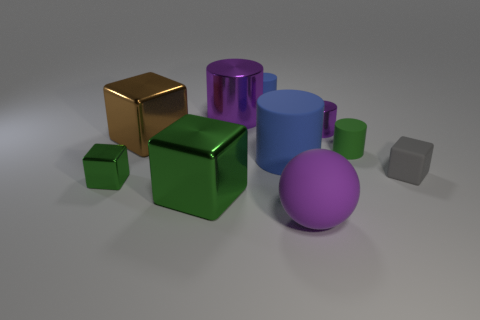The small metallic object that is the same color as the big matte sphere is what shape?
Offer a terse response. Cylinder. Is there anything else of the same color as the small matte cube?
Offer a very short reply. No. Do the green cylinder and the rubber cube have the same size?
Provide a succinct answer. Yes. How many things are either tiny green objects on the right side of the large shiny cylinder or green objects that are to the right of the large matte sphere?
Offer a terse response. 1. There is a large thing behind the cube behind the gray cube; what is its material?
Provide a succinct answer. Metal. What number of other objects are there of the same material as the large green block?
Offer a terse response. 4. Do the small green metal thing and the big brown thing have the same shape?
Ensure brevity in your answer.  Yes. There is a matte cylinder that is behind the brown metallic cube; what size is it?
Provide a succinct answer. Small. Does the gray block have the same size as the shiny cylinder left of the tiny blue object?
Provide a succinct answer. No. Is the number of matte things in front of the big blue rubber cylinder less than the number of metallic blocks?
Your answer should be compact. Yes. 